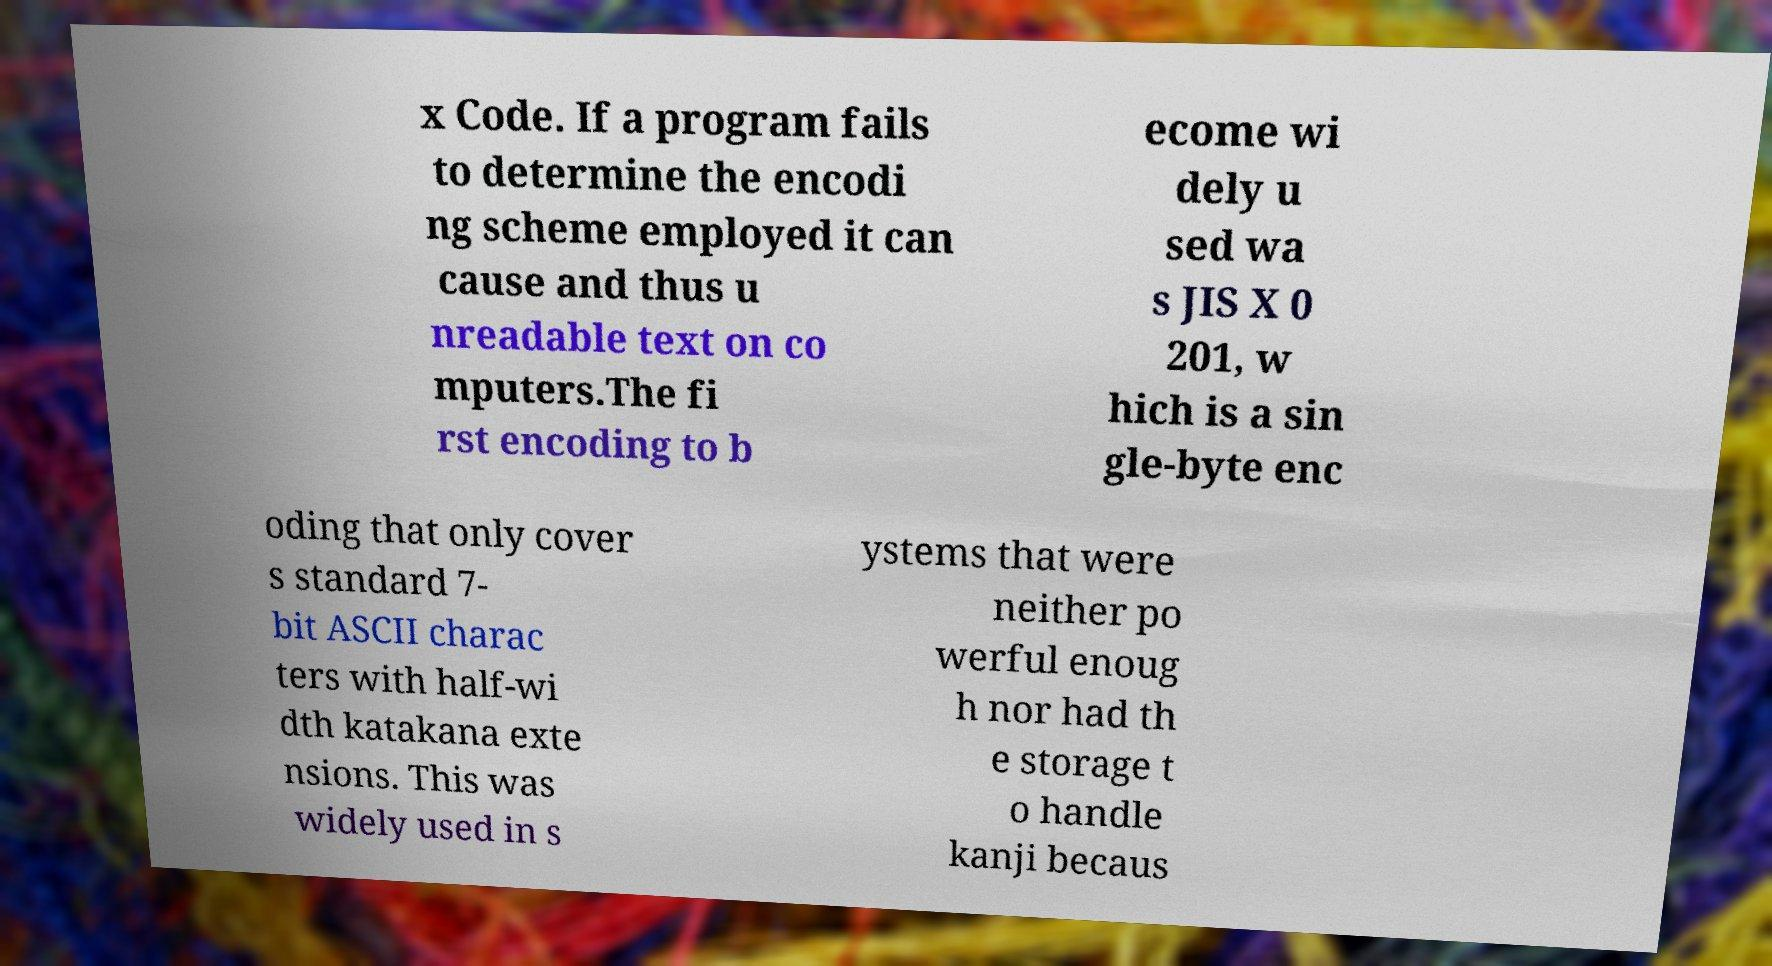Can you accurately transcribe the text from the provided image for me? x Code. If a program fails to determine the encodi ng scheme employed it can cause and thus u nreadable text on co mputers.The fi rst encoding to b ecome wi dely u sed wa s JIS X 0 201, w hich is a sin gle-byte enc oding that only cover s standard 7- bit ASCII charac ters with half-wi dth katakana exte nsions. This was widely used in s ystems that were neither po werful enoug h nor had th e storage t o handle kanji becaus 